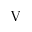Convert formula to latex. <formula><loc_0><loc_0><loc_500><loc_500>V</formula> 